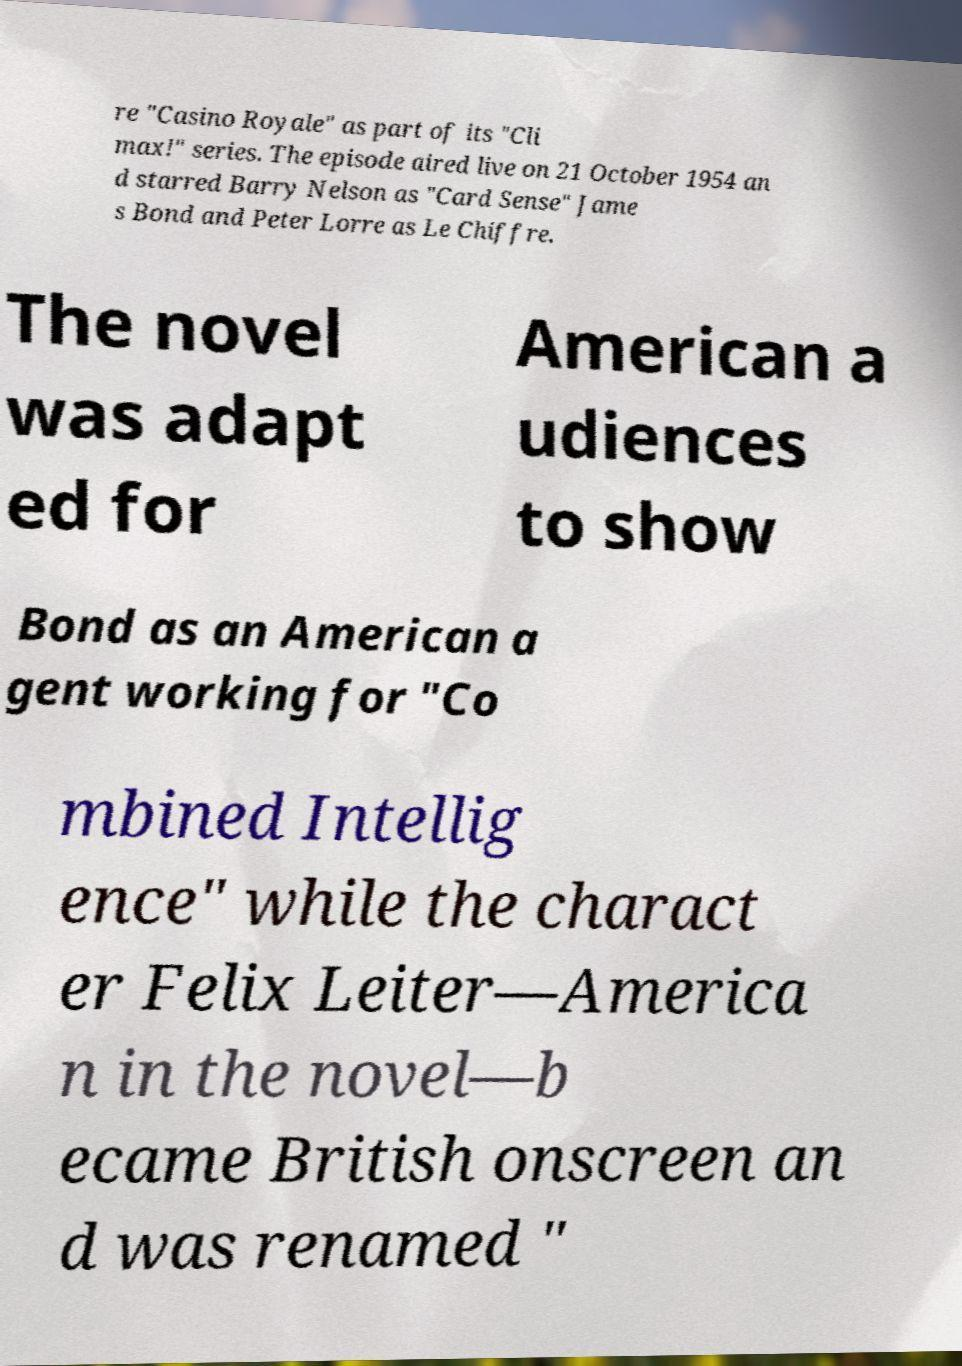What messages or text are displayed in this image? I need them in a readable, typed format. re "Casino Royale" as part of its "Cli max!" series. The episode aired live on 21 October 1954 an d starred Barry Nelson as "Card Sense" Jame s Bond and Peter Lorre as Le Chiffre. The novel was adapt ed for American a udiences to show Bond as an American a gent working for "Co mbined Intellig ence" while the charact er Felix Leiter—America n in the novel—b ecame British onscreen an d was renamed " 